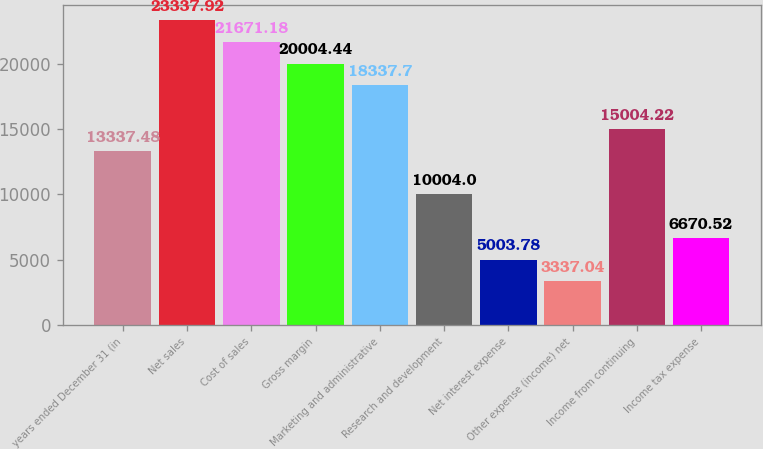<chart> <loc_0><loc_0><loc_500><loc_500><bar_chart><fcel>years ended December 31 (in<fcel>Net sales<fcel>Cost of sales<fcel>Gross margin<fcel>Marketing and administrative<fcel>Research and development<fcel>Net interest expense<fcel>Other expense (income) net<fcel>Income from continuing<fcel>Income tax expense<nl><fcel>13337.5<fcel>23337.9<fcel>21671.2<fcel>20004.4<fcel>18337.7<fcel>10004<fcel>5003.78<fcel>3337.04<fcel>15004.2<fcel>6670.52<nl></chart> 